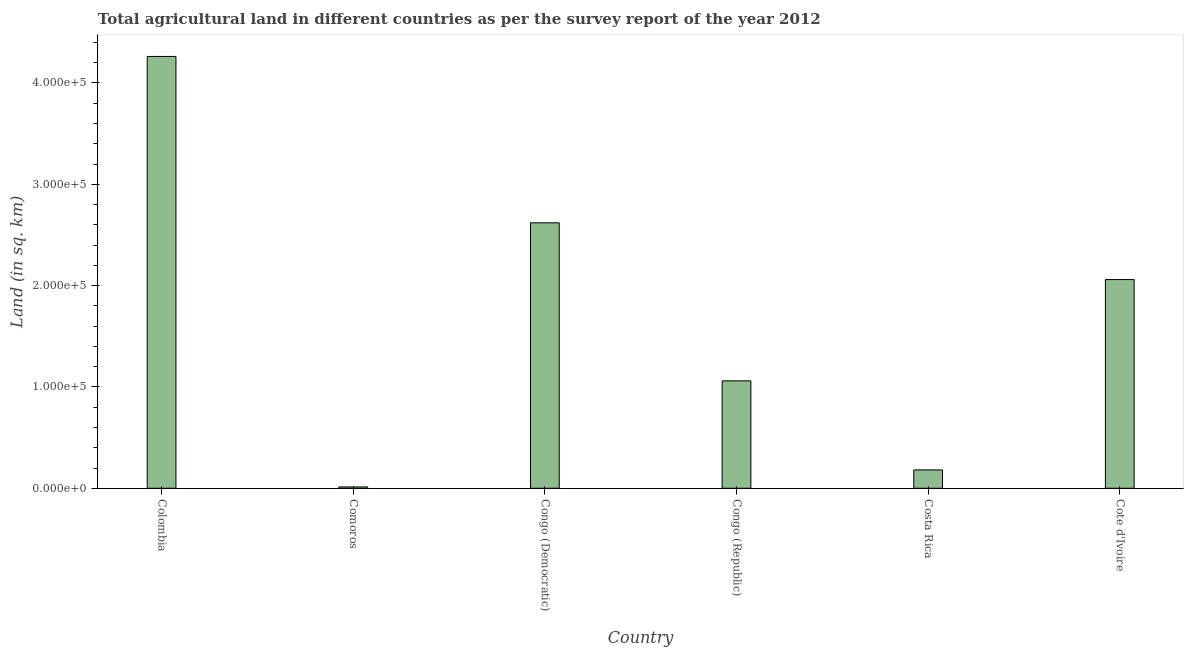What is the title of the graph?
Your answer should be very brief. Total agricultural land in different countries as per the survey report of the year 2012. What is the label or title of the Y-axis?
Keep it short and to the point. Land (in sq. km). What is the agricultural land in Congo (Republic)?
Keep it short and to the point. 1.06e+05. Across all countries, what is the maximum agricultural land?
Offer a very short reply. 4.26e+05. Across all countries, what is the minimum agricultural land?
Your answer should be compact. 1330. In which country was the agricultural land maximum?
Give a very brief answer. Colombia. In which country was the agricultural land minimum?
Your answer should be very brief. Comoros. What is the sum of the agricultural land?
Your response must be concise. 1.02e+06. What is the difference between the agricultural land in Comoros and Congo (Republic)?
Provide a short and direct response. -1.05e+05. What is the average agricultural land per country?
Provide a succinct answer. 1.70e+05. What is the median agricultural land?
Offer a very short reply. 1.56e+05. In how many countries, is the agricultural land greater than 300000 sq. km?
Ensure brevity in your answer.  1. What is the ratio of the agricultural land in Comoros to that in Costa Rica?
Offer a very short reply. 0.07. What is the difference between the highest and the second highest agricultural land?
Your response must be concise. 1.64e+05. Is the sum of the agricultural land in Comoros and Congo (Democratic) greater than the maximum agricultural land across all countries?
Offer a terse response. No. What is the difference between the highest and the lowest agricultural land?
Your response must be concise. 4.25e+05. In how many countries, is the agricultural land greater than the average agricultural land taken over all countries?
Provide a short and direct response. 3. How many bars are there?
Make the answer very short. 6. What is the difference between two consecutive major ticks on the Y-axis?
Offer a terse response. 1.00e+05. Are the values on the major ticks of Y-axis written in scientific E-notation?
Your answer should be compact. Yes. What is the Land (in sq. km) of Colombia?
Make the answer very short. 4.26e+05. What is the Land (in sq. km) in Comoros?
Provide a succinct answer. 1330. What is the Land (in sq. km) in Congo (Democratic)?
Provide a short and direct response. 2.62e+05. What is the Land (in sq. km) in Congo (Republic)?
Give a very brief answer. 1.06e+05. What is the Land (in sq. km) in Costa Rica?
Provide a succinct answer. 1.81e+04. What is the Land (in sq. km) of Cote d'Ivoire?
Keep it short and to the point. 2.06e+05. What is the difference between the Land (in sq. km) in Colombia and Comoros?
Offer a terse response. 4.25e+05. What is the difference between the Land (in sq. km) in Colombia and Congo (Democratic)?
Your answer should be compact. 1.64e+05. What is the difference between the Land (in sq. km) in Colombia and Congo (Republic)?
Your response must be concise. 3.20e+05. What is the difference between the Land (in sq. km) in Colombia and Costa Rica?
Keep it short and to the point. 4.08e+05. What is the difference between the Land (in sq. km) in Colombia and Cote d'Ivoire?
Offer a terse response. 2.20e+05. What is the difference between the Land (in sq. km) in Comoros and Congo (Democratic)?
Make the answer very short. -2.61e+05. What is the difference between the Land (in sq. km) in Comoros and Congo (Republic)?
Your answer should be very brief. -1.05e+05. What is the difference between the Land (in sq. km) in Comoros and Costa Rica?
Your answer should be compact. -1.68e+04. What is the difference between the Land (in sq. km) in Comoros and Cote d'Ivoire?
Your answer should be compact. -2.05e+05. What is the difference between the Land (in sq. km) in Congo (Democratic) and Congo (Republic)?
Your answer should be compact. 1.56e+05. What is the difference between the Land (in sq. km) in Congo (Democratic) and Costa Rica?
Your response must be concise. 2.44e+05. What is the difference between the Land (in sq. km) in Congo (Democratic) and Cote d'Ivoire?
Provide a short and direct response. 5.60e+04. What is the difference between the Land (in sq. km) in Congo (Republic) and Costa Rica?
Your response must be concise. 8.79e+04. What is the difference between the Land (in sq. km) in Congo (Republic) and Cote d'Ivoire?
Your response must be concise. -1.00e+05. What is the difference between the Land (in sq. km) in Costa Rica and Cote d'Ivoire?
Give a very brief answer. -1.88e+05. What is the ratio of the Land (in sq. km) in Colombia to that in Comoros?
Make the answer very short. 320.43. What is the ratio of the Land (in sq. km) in Colombia to that in Congo (Democratic)?
Your answer should be compact. 1.63. What is the ratio of the Land (in sq. km) in Colombia to that in Congo (Republic)?
Keep it short and to the point. 4.02. What is the ratio of the Land (in sq. km) in Colombia to that in Costa Rica?
Your response must be concise. 23.52. What is the ratio of the Land (in sq. km) in Colombia to that in Cote d'Ivoire?
Ensure brevity in your answer.  2.07. What is the ratio of the Land (in sq. km) in Comoros to that in Congo (Democratic)?
Your response must be concise. 0.01. What is the ratio of the Land (in sq. km) in Comoros to that in Congo (Republic)?
Provide a short and direct response. 0.01. What is the ratio of the Land (in sq. km) in Comoros to that in Costa Rica?
Your answer should be very brief. 0.07. What is the ratio of the Land (in sq. km) in Comoros to that in Cote d'Ivoire?
Provide a short and direct response. 0.01. What is the ratio of the Land (in sq. km) in Congo (Democratic) to that in Congo (Republic)?
Your response must be concise. 2.47. What is the ratio of the Land (in sq. km) in Congo (Democratic) to that in Costa Rica?
Provide a succinct answer. 14.46. What is the ratio of the Land (in sq. km) in Congo (Democratic) to that in Cote d'Ivoire?
Keep it short and to the point. 1.27. What is the ratio of the Land (in sq. km) in Congo (Republic) to that in Costa Rica?
Your response must be concise. 5.85. What is the ratio of the Land (in sq. km) in Congo (Republic) to that in Cote d'Ivoire?
Offer a terse response. 0.52. What is the ratio of the Land (in sq. km) in Costa Rica to that in Cote d'Ivoire?
Provide a short and direct response. 0.09. 